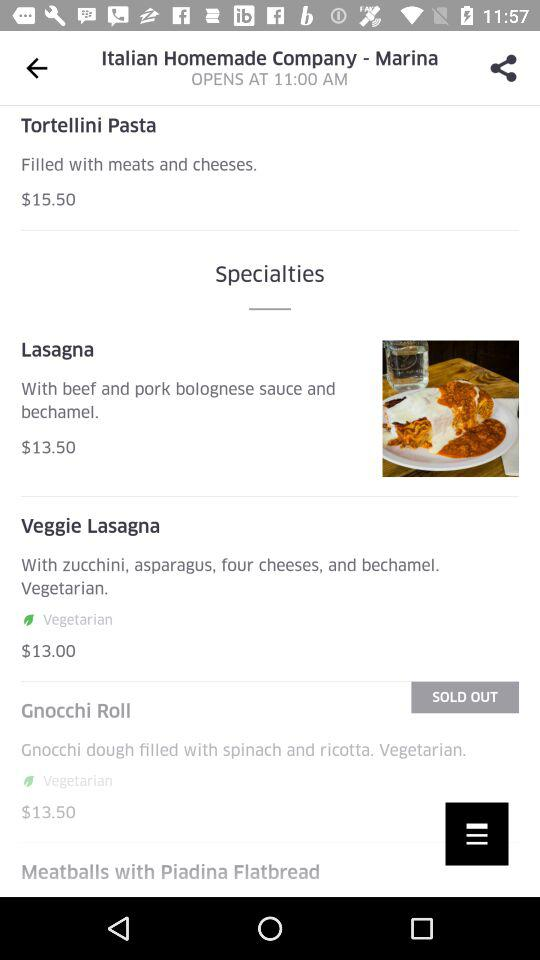What is the price of "Tortellini Pasta"? The price of "Tortellini Pasta" is $15.50. 